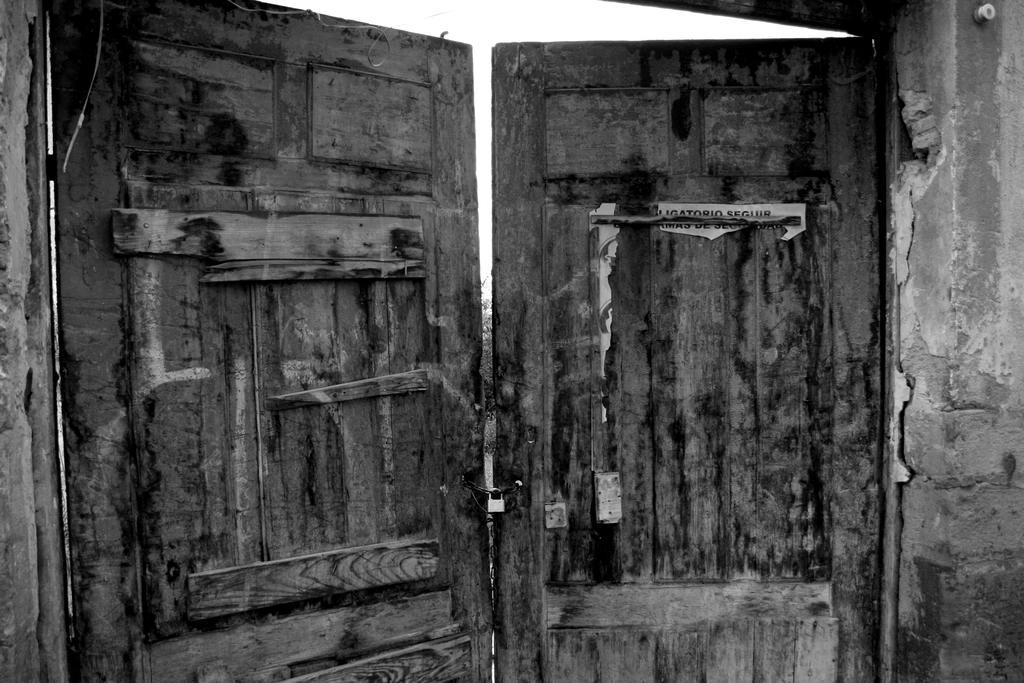Could you give a brief overview of what you see in this image? In this picture we can observe wooden doors here. There is a lock. In the right side we can observe a wall. In the background there is a sky. 